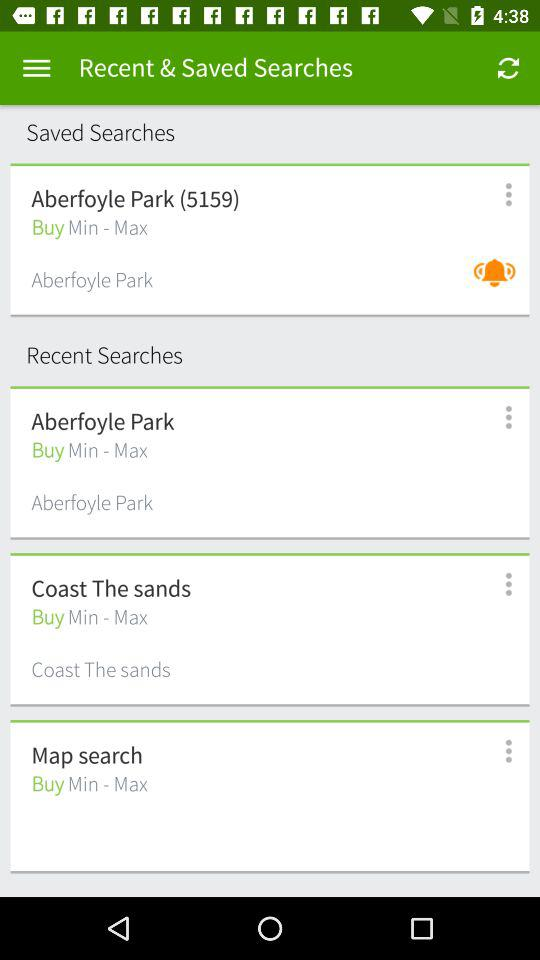What are the saved searches? The saved search is Aberfoyle Park (5159). 